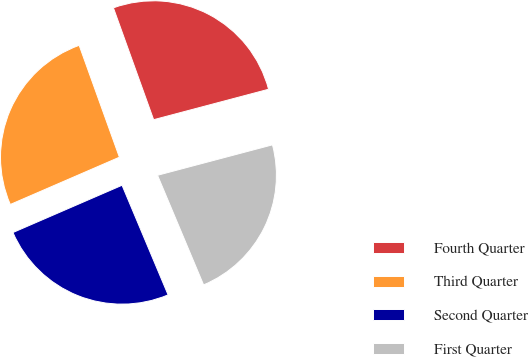Convert chart. <chart><loc_0><loc_0><loc_500><loc_500><pie_chart><fcel>Fourth Quarter<fcel>Third Quarter<fcel>Second Quarter<fcel>First Quarter<nl><fcel>26.37%<fcel>26.01%<fcel>24.82%<fcel>22.79%<nl></chart> 